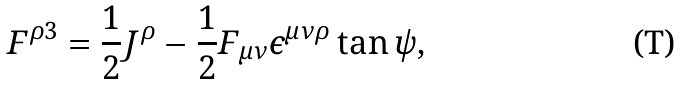Convert formula to latex. <formula><loc_0><loc_0><loc_500><loc_500>F ^ { \rho 3 } = \frac { 1 } { 2 } J ^ { \rho } - \frac { 1 } { 2 } F _ { \mu \nu } \epsilon ^ { \mu \nu \rho } \tan \psi ,</formula> 